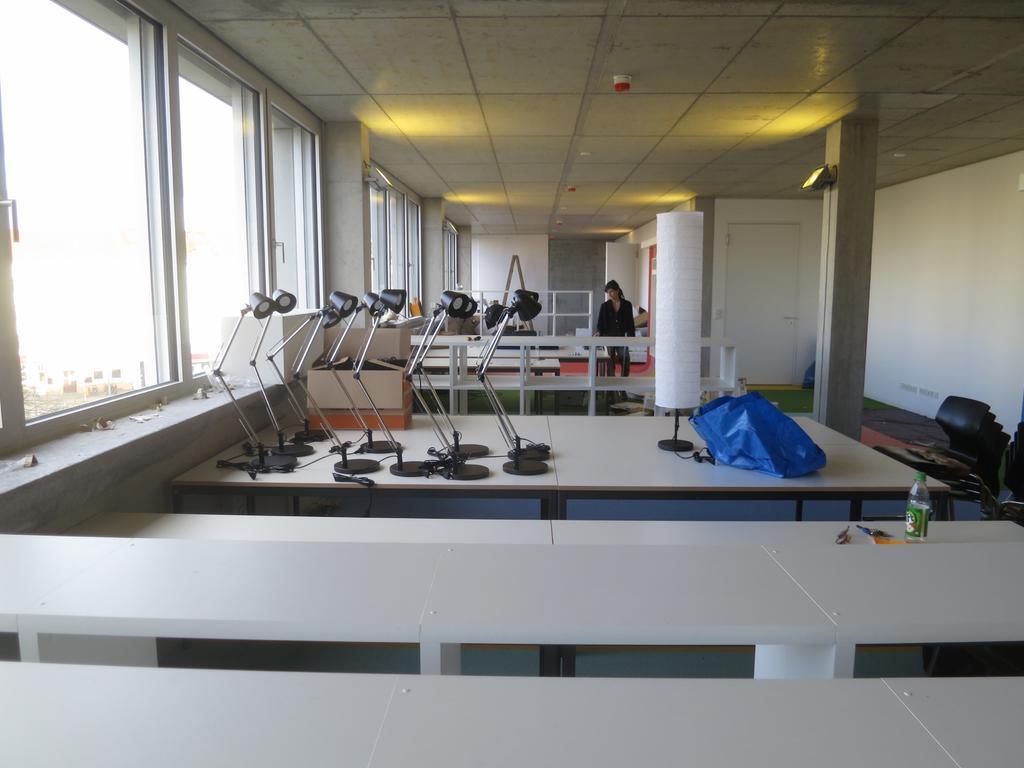Can you describe this image briefly? In this image I can see a table and number of lamps on it. In the background I can see a person. 